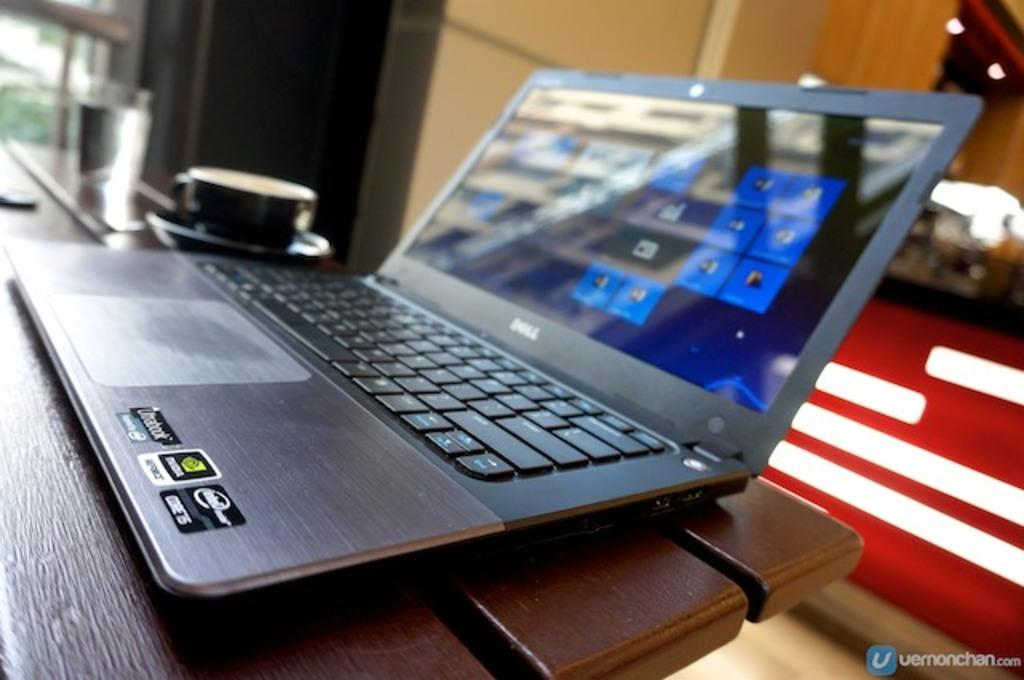What is located in the foreground of the image? There is a table in the foreground of the image. What electronic device is on the table? A laptop is present on the table. What type of beverage container is on the table? There is a tea cup on the table. What can be seen in the image besides the table and its contents? Text is visible in the image, and there is a wall in the background. What can be seen in the background of the image? Trees and lights are present in the background of the image. Can you determine the time of day when the image was taken? The image was likely taken during the day, as there is no indication of darkness or artificial lighting. What type of sack is being used for the competition in the image? There is no sack or competition present in the image. How does the person in the image prepare for their bath? There is no person or bath visible in the image. 